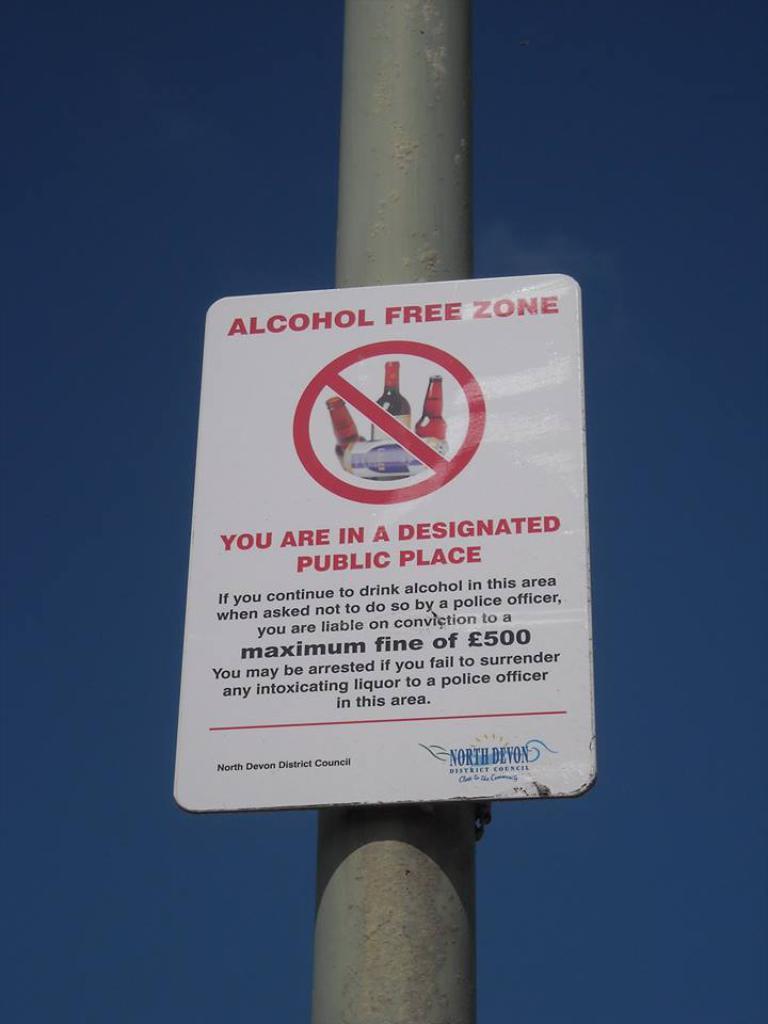What is the maximum fine?
Ensure brevity in your answer.  500. 